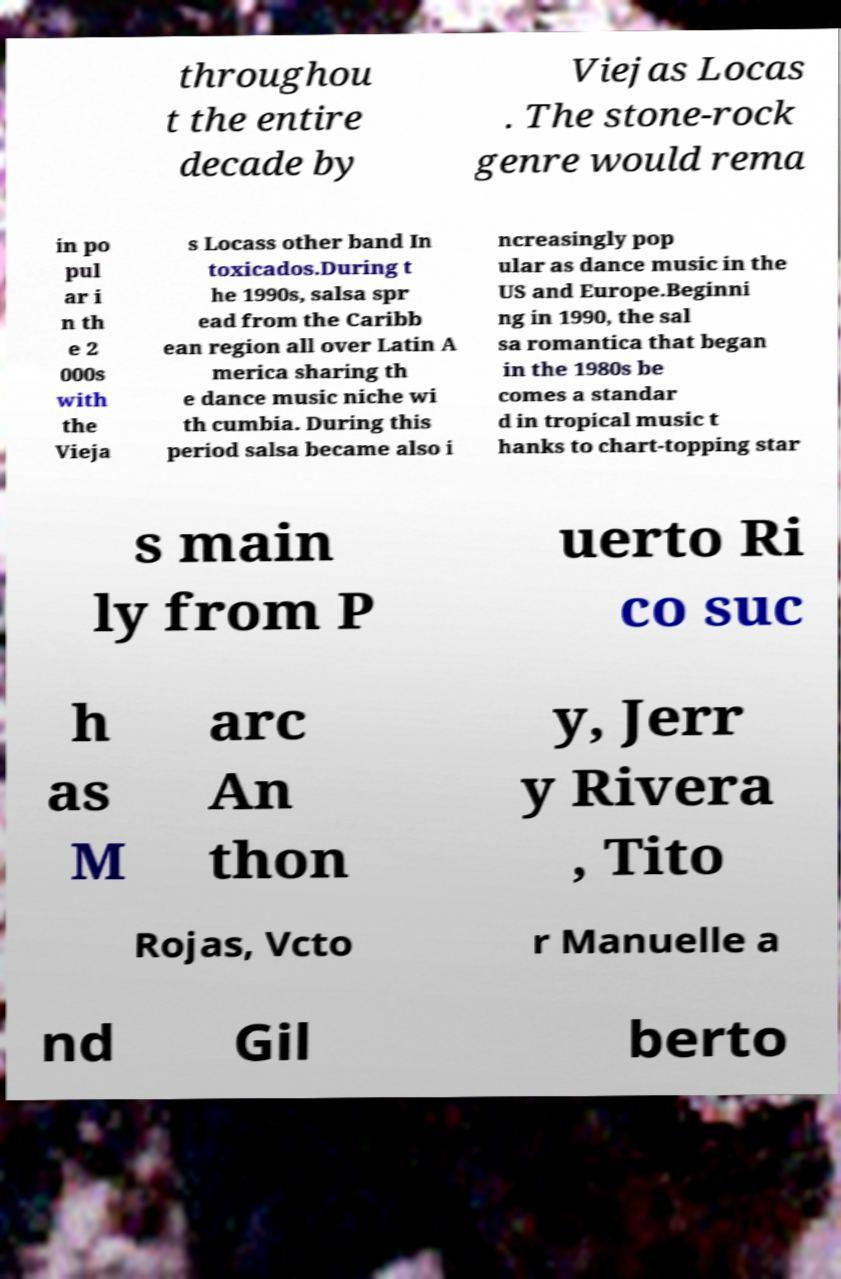Can you accurately transcribe the text from the provided image for me? throughou t the entire decade by Viejas Locas . The stone-rock genre would rema in po pul ar i n th e 2 000s with the Vieja s Locass other band In toxicados.During t he 1990s, salsa spr ead from the Caribb ean region all over Latin A merica sharing th e dance music niche wi th cumbia. During this period salsa became also i ncreasingly pop ular as dance music in the US and Europe.Beginni ng in 1990, the sal sa romantica that began in the 1980s be comes a standar d in tropical music t hanks to chart-topping star s main ly from P uerto Ri co suc h as M arc An thon y, Jerr y Rivera , Tito Rojas, Vcto r Manuelle a nd Gil berto 